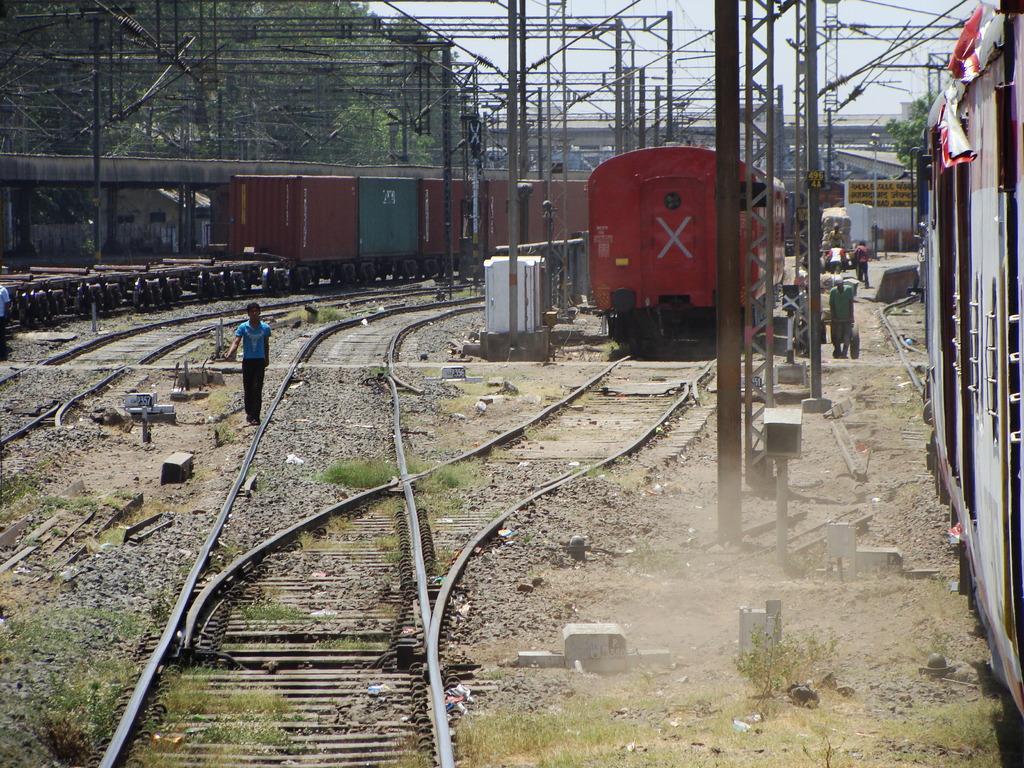Please provide a concise description of this image. Here we can see trains on the railway tracks and we can see few persons and some metal objects. In the background there are trees,metal poles,hoardings,few persons pushing carts,bridge and sky. 